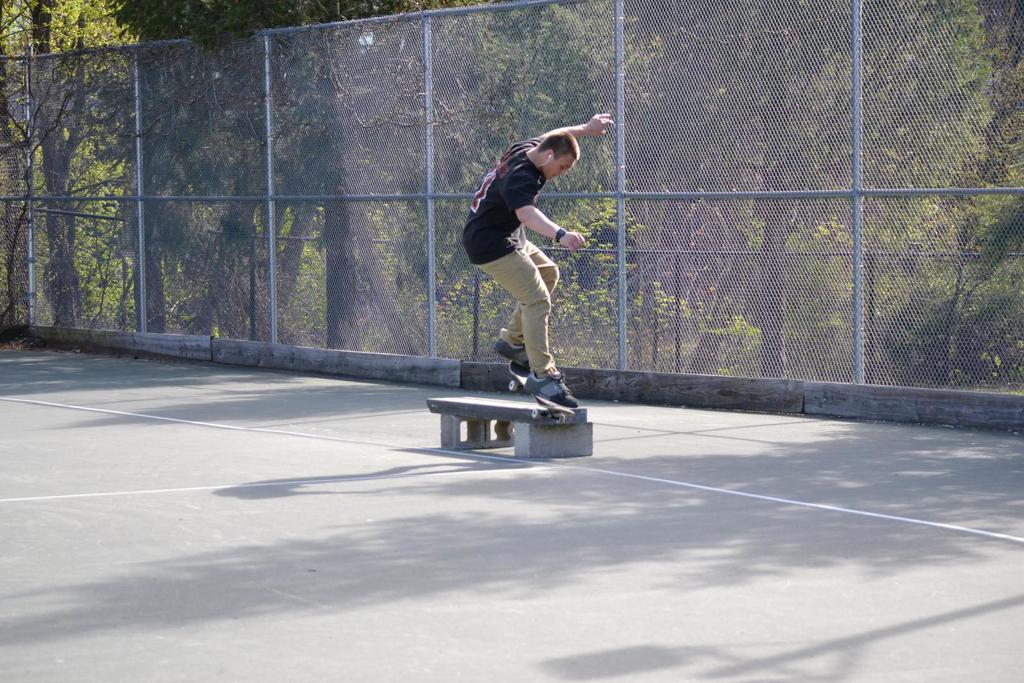What is the main subject of the image? There is a person in the image. What is the person wearing? The person is wearing a black T-shirt. What activity is the person engaged in? The person is skating on a skateboard. What can be seen in the background of the image? There is a fence and trees in the background of the image. What type of garden can be seen in the background of the image? There is no garden visible in the background of the image; it features a fence and trees. What is the person measuring in the image? There is no indication of measuring in the image. 